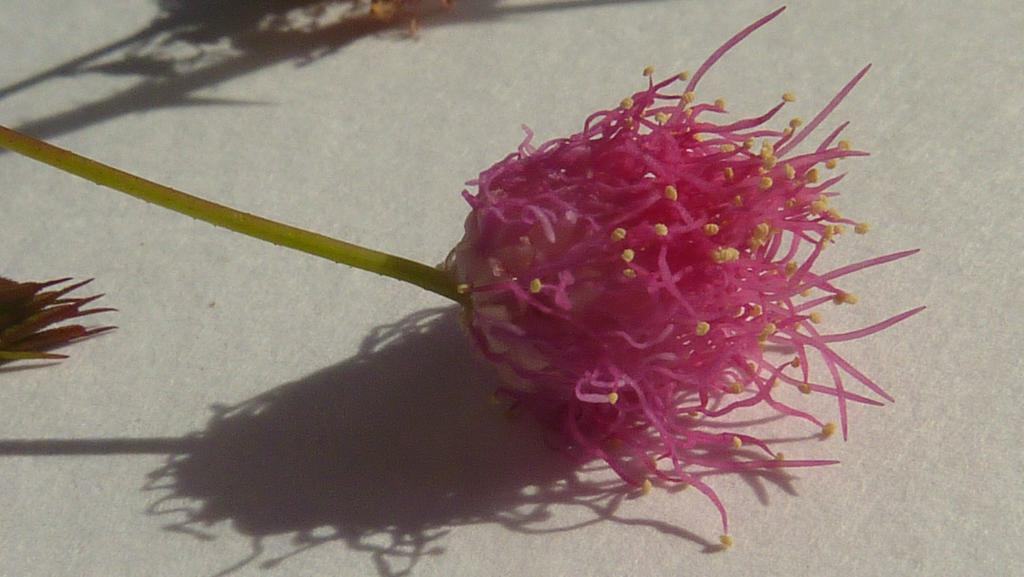What type of plant is present in the image? There is a flower with a stem in the image. Are there any other flowers visible in the image? Yes, there appears to be another flower on the left side of the image. What can be seen in the background of the image? There are shadows visible in the background of the image. What degree does the flower have in the image? The flower does not have a degree, as it is a plant and not a person or entity capable of obtaining a degree. 